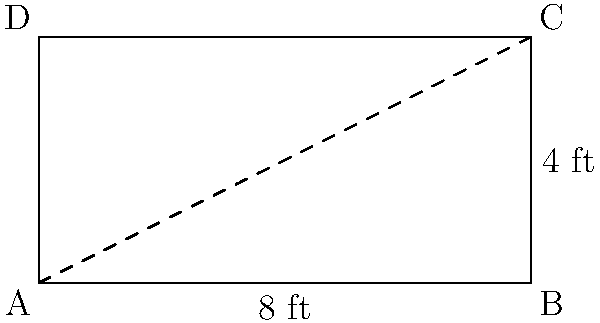As a food critic, you're reviewing a new upscale restaurant. The maitre d' informs you that their exquisite rectangular dining tables are crafted to precise dimensions. If a table measures 8 feet in length and 4 feet in width, what is its perimeter? Express your answer in feet. To find the perimeter of the rectangular dining table, we need to follow these steps:

1. Identify the formula for the perimeter of a rectangle:
   Perimeter = 2 × (length + width)

2. Substitute the given dimensions:
   Length = 8 feet
   Width = 4 feet

3. Apply the formula:
   Perimeter = 2 × (8 + 4)
   
4. Perform the addition inside the parentheses:
   Perimeter = 2 × 12

5. Multiply:
   Perimeter = 24

Therefore, the perimeter of the dining table is 24 feet.
Answer: 24 ft 